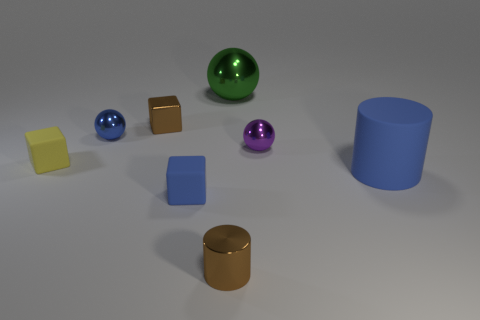Subtract all red cubes. Subtract all blue cylinders. How many cubes are left? 3 Add 2 brown balls. How many objects exist? 10 Subtract all balls. How many objects are left? 5 Add 8 tiny yellow objects. How many tiny yellow objects are left? 9 Add 4 gray balls. How many gray balls exist? 4 Subtract 1 blue cylinders. How many objects are left? 7 Subtract all green cubes. Subtract all purple shiny things. How many objects are left? 7 